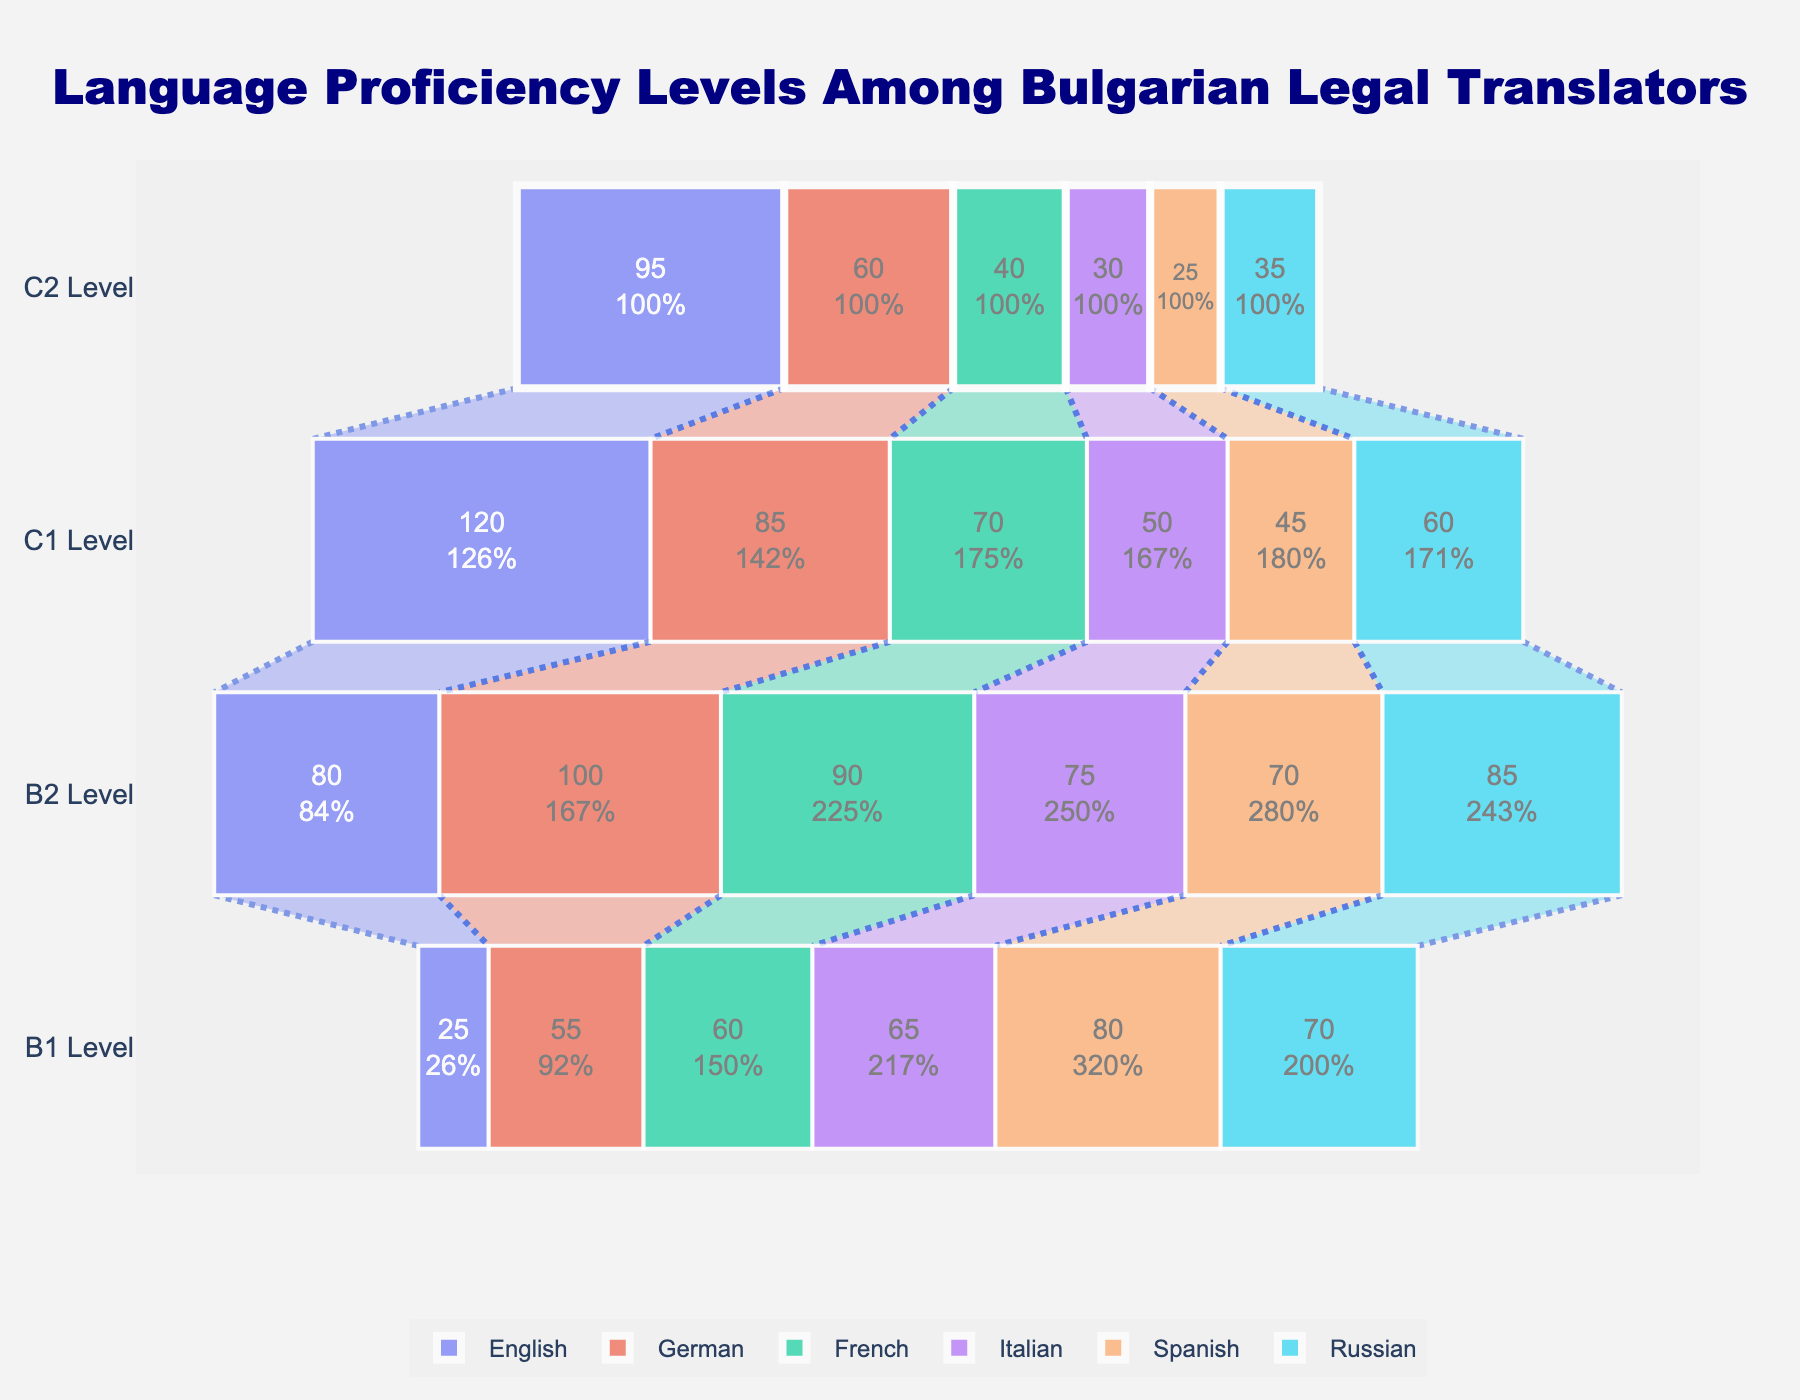What is the most common language proficiency level for English among Bulgarian legal translators? By inspecting the funnel chart, observe the counts of translators at each proficiency level (C2, C1, B2, B1) for English. The C1 Level has 120 translators, which is the highest count among the levels for English.
Answer: C1 Level Which language has the highest number of C2 proficiency level translators? Look at the counts for the C2 Level of each language in the funnel chart. English has the highest count at this level with 95 translators.
Answer: English Compare the B1 proficiency levels of German and Spanish; which one has more translators? Investigate the number of translators at the B1 Level for both German and Spanish. German has 55 translators, while Spanish has 80 translators at this level.
Answer: Spanish What is the sum of all translators who have B2 proficiency level in French? Add up the number of translators at the B2 Level for French. The count is already given as 90. So, the sum is 90.
Answer: 90 How many more translators have C1 proficiency level in German compared to C2 proficiency level in German? Subtract the number of German translators at C2 proficiency (60) from the number at C1 proficiency (85). The difference is 85 - 60 = 25.
Answer: 25 What is the average number of translators at the B1 proficiency level across all languages? Add the number of B1 translators for each language (25 + 55 + 60 + 65 + 80 + 70 = 355) and divide by the number of languages (6). The average is 355 / 6 ≈ 59.17.
Answer: 59.17 Which language has the smallest number of translators at any proficiency level and what is that number? Find the smallest count in the funnel chart across all proficiency levels and languages. Spanish at C2 Level has the smallest number of translators, which is 25.
Answer: Spanish, 25 What is the total number of translators with either C1 or C2 proficiency level across all languages? Add the total number of translators at C1 and C2 Levels for all languages: (95 + 120 + 60 + 85 + 40 + 70 + 30 + 50 + 25 + 45 + 35 + 60 = 715). The sum is 715.
Answer: 715 Which language has a greater decrease in the number of translators from C1 to B2, French or Italian? Calculate the difference between C1 and B2 for both French (70 - 90 = -20) and Italian (50 - 75 = -25). French has a decrease of -20, while Italian has a decrease of -25.
Answer: Italian 